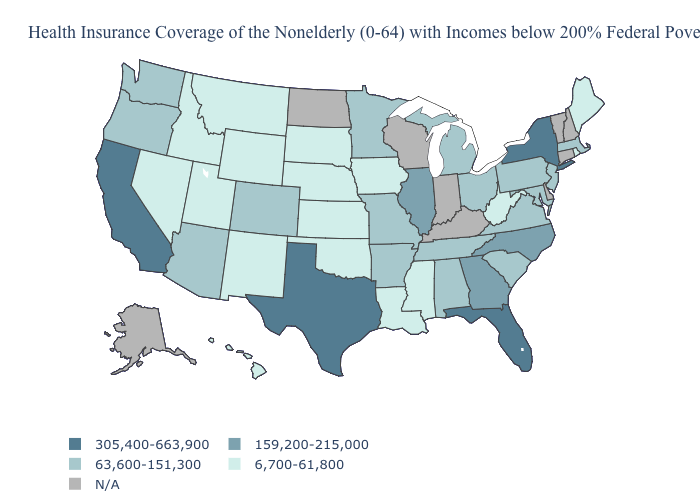Does Rhode Island have the highest value in the Northeast?
Concise answer only. No. What is the value of Vermont?
Short answer required. N/A. Which states have the lowest value in the USA?
Concise answer only. Hawaii, Idaho, Iowa, Kansas, Louisiana, Maine, Mississippi, Montana, Nebraska, Nevada, New Mexico, Oklahoma, Rhode Island, South Dakota, Utah, West Virginia, Wyoming. What is the value of Mississippi?
Quick response, please. 6,700-61,800. Among the states that border New Jersey , which have the lowest value?
Quick response, please. Pennsylvania. Name the states that have a value in the range 6,700-61,800?
Answer briefly. Hawaii, Idaho, Iowa, Kansas, Louisiana, Maine, Mississippi, Montana, Nebraska, Nevada, New Mexico, Oklahoma, Rhode Island, South Dakota, Utah, West Virginia, Wyoming. Does the map have missing data?
Quick response, please. Yes. Does Texas have the highest value in the USA?
Keep it brief. Yes. What is the lowest value in the MidWest?
Give a very brief answer. 6,700-61,800. Name the states that have a value in the range 63,600-151,300?
Quick response, please. Alabama, Arizona, Arkansas, Colorado, Maryland, Massachusetts, Michigan, Minnesota, Missouri, New Jersey, Ohio, Oregon, Pennsylvania, South Carolina, Tennessee, Virginia, Washington. Is the legend a continuous bar?
Give a very brief answer. No. What is the value of Virginia?
Short answer required. 63,600-151,300. What is the value of Nebraska?
Quick response, please. 6,700-61,800. 